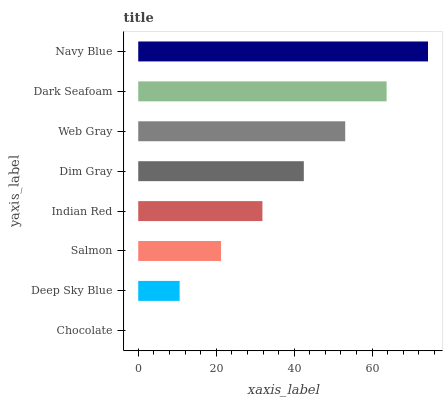Is Chocolate the minimum?
Answer yes or no. Yes. Is Navy Blue the maximum?
Answer yes or no. Yes. Is Deep Sky Blue the minimum?
Answer yes or no. No. Is Deep Sky Blue the maximum?
Answer yes or no. No. Is Deep Sky Blue greater than Chocolate?
Answer yes or no. Yes. Is Chocolate less than Deep Sky Blue?
Answer yes or no. Yes. Is Chocolate greater than Deep Sky Blue?
Answer yes or no. No. Is Deep Sky Blue less than Chocolate?
Answer yes or no. No. Is Dim Gray the high median?
Answer yes or no. Yes. Is Indian Red the low median?
Answer yes or no. Yes. Is Salmon the high median?
Answer yes or no. No. Is Salmon the low median?
Answer yes or no. No. 